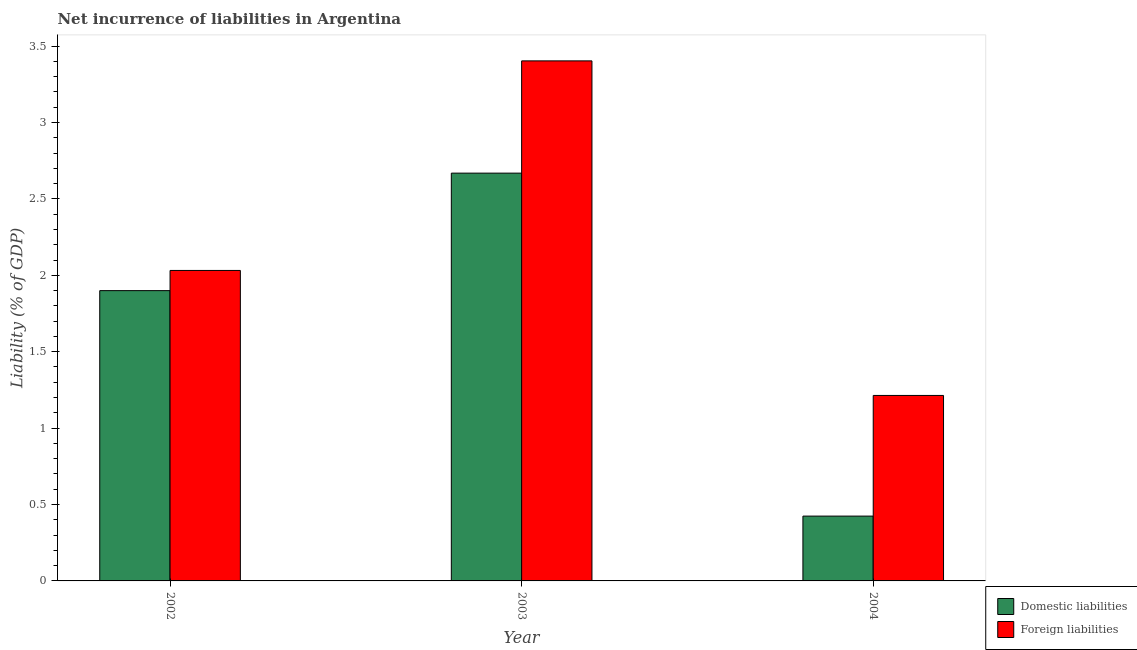How many different coloured bars are there?
Ensure brevity in your answer.  2. How many groups of bars are there?
Your response must be concise. 3. Are the number of bars per tick equal to the number of legend labels?
Provide a succinct answer. Yes. Are the number of bars on each tick of the X-axis equal?
Offer a very short reply. Yes. How many bars are there on the 3rd tick from the left?
Give a very brief answer. 2. How many bars are there on the 1st tick from the right?
Keep it short and to the point. 2. What is the label of the 3rd group of bars from the left?
Offer a very short reply. 2004. What is the incurrence of domestic liabilities in 2002?
Provide a short and direct response. 1.9. Across all years, what is the maximum incurrence of domestic liabilities?
Your response must be concise. 2.67. Across all years, what is the minimum incurrence of domestic liabilities?
Ensure brevity in your answer.  0.42. What is the total incurrence of foreign liabilities in the graph?
Provide a short and direct response. 6.65. What is the difference between the incurrence of foreign liabilities in 2002 and that in 2003?
Give a very brief answer. -1.37. What is the difference between the incurrence of foreign liabilities in 2003 and the incurrence of domestic liabilities in 2002?
Offer a very short reply. 1.37. What is the average incurrence of foreign liabilities per year?
Give a very brief answer. 2.22. In how many years, is the incurrence of domestic liabilities greater than 1.6 %?
Provide a short and direct response. 2. What is the ratio of the incurrence of domestic liabilities in 2003 to that in 2004?
Provide a succinct answer. 6.29. What is the difference between the highest and the second highest incurrence of domestic liabilities?
Give a very brief answer. 0.77. What is the difference between the highest and the lowest incurrence of foreign liabilities?
Ensure brevity in your answer.  2.19. What does the 2nd bar from the left in 2003 represents?
Your answer should be compact. Foreign liabilities. What does the 2nd bar from the right in 2004 represents?
Provide a short and direct response. Domestic liabilities. How many bars are there?
Provide a succinct answer. 6. Are all the bars in the graph horizontal?
Offer a very short reply. No. How many years are there in the graph?
Your response must be concise. 3. Where does the legend appear in the graph?
Offer a very short reply. Bottom right. How are the legend labels stacked?
Provide a succinct answer. Vertical. What is the title of the graph?
Your answer should be compact. Net incurrence of liabilities in Argentina. What is the label or title of the Y-axis?
Keep it short and to the point. Liability (% of GDP). What is the Liability (% of GDP) of Domestic liabilities in 2002?
Provide a short and direct response. 1.9. What is the Liability (% of GDP) of Foreign liabilities in 2002?
Keep it short and to the point. 2.03. What is the Liability (% of GDP) of Domestic liabilities in 2003?
Offer a terse response. 2.67. What is the Liability (% of GDP) of Foreign liabilities in 2003?
Provide a short and direct response. 3.4. What is the Liability (% of GDP) in Domestic liabilities in 2004?
Give a very brief answer. 0.42. What is the Liability (% of GDP) of Foreign liabilities in 2004?
Your answer should be very brief. 1.21. Across all years, what is the maximum Liability (% of GDP) of Domestic liabilities?
Ensure brevity in your answer.  2.67. Across all years, what is the maximum Liability (% of GDP) in Foreign liabilities?
Provide a succinct answer. 3.4. Across all years, what is the minimum Liability (% of GDP) of Domestic liabilities?
Your answer should be compact. 0.42. Across all years, what is the minimum Liability (% of GDP) in Foreign liabilities?
Your response must be concise. 1.21. What is the total Liability (% of GDP) of Domestic liabilities in the graph?
Give a very brief answer. 4.99. What is the total Liability (% of GDP) of Foreign liabilities in the graph?
Offer a very short reply. 6.65. What is the difference between the Liability (% of GDP) of Domestic liabilities in 2002 and that in 2003?
Your answer should be compact. -0.77. What is the difference between the Liability (% of GDP) in Foreign liabilities in 2002 and that in 2003?
Provide a succinct answer. -1.37. What is the difference between the Liability (% of GDP) in Domestic liabilities in 2002 and that in 2004?
Your response must be concise. 1.48. What is the difference between the Liability (% of GDP) in Foreign liabilities in 2002 and that in 2004?
Give a very brief answer. 0.82. What is the difference between the Liability (% of GDP) in Domestic liabilities in 2003 and that in 2004?
Your response must be concise. 2.24. What is the difference between the Liability (% of GDP) in Foreign liabilities in 2003 and that in 2004?
Make the answer very short. 2.19. What is the difference between the Liability (% of GDP) of Domestic liabilities in 2002 and the Liability (% of GDP) of Foreign liabilities in 2003?
Ensure brevity in your answer.  -1.5. What is the difference between the Liability (% of GDP) in Domestic liabilities in 2002 and the Liability (% of GDP) in Foreign liabilities in 2004?
Offer a very short reply. 0.69. What is the difference between the Liability (% of GDP) of Domestic liabilities in 2003 and the Liability (% of GDP) of Foreign liabilities in 2004?
Give a very brief answer. 1.45. What is the average Liability (% of GDP) in Domestic liabilities per year?
Provide a short and direct response. 1.66. What is the average Liability (% of GDP) in Foreign liabilities per year?
Provide a succinct answer. 2.22. In the year 2002, what is the difference between the Liability (% of GDP) of Domestic liabilities and Liability (% of GDP) of Foreign liabilities?
Your answer should be very brief. -0.13. In the year 2003, what is the difference between the Liability (% of GDP) in Domestic liabilities and Liability (% of GDP) in Foreign liabilities?
Your response must be concise. -0.73. In the year 2004, what is the difference between the Liability (% of GDP) of Domestic liabilities and Liability (% of GDP) of Foreign liabilities?
Offer a very short reply. -0.79. What is the ratio of the Liability (% of GDP) in Domestic liabilities in 2002 to that in 2003?
Your answer should be compact. 0.71. What is the ratio of the Liability (% of GDP) in Foreign liabilities in 2002 to that in 2003?
Keep it short and to the point. 0.6. What is the ratio of the Liability (% of GDP) in Domestic liabilities in 2002 to that in 2004?
Provide a short and direct response. 4.48. What is the ratio of the Liability (% of GDP) of Foreign liabilities in 2002 to that in 2004?
Offer a very short reply. 1.67. What is the ratio of the Liability (% of GDP) of Domestic liabilities in 2003 to that in 2004?
Provide a succinct answer. 6.29. What is the ratio of the Liability (% of GDP) in Foreign liabilities in 2003 to that in 2004?
Ensure brevity in your answer.  2.8. What is the difference between the highest and the second highest Liability (% of GDP) of Domestic liabilities?
Keep it short and to the point. 0.77. What is the difference between the highest and the second highest Liability (% of GDP) in Foreign liabilities?
Offer a very short reply. 1.37. What is the difference between the highest and the lowest Liability (% of GDP) of Domestic liabilities?
Your response must be concise. 2.24. What is the difference between the highest and the lowest Liability (% of GDP) of Foreign liabilities?
Your response must be concise. 2.19. 